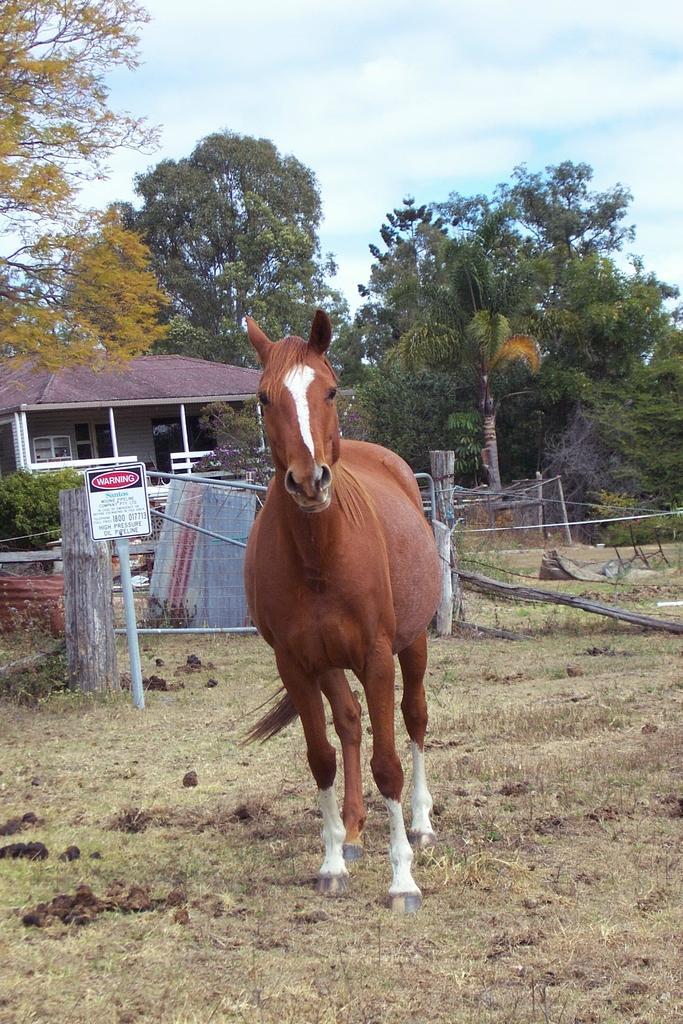Could you give a brief overview of what you see in this image? In the picture we can see a grass surface on it we can see a horse which is brown in color and some part white in color to its legs and behind it we can see a gate and behind it we can see some plants and house with shed and poles to it and in the background we can see some trees and sky with clouds. 